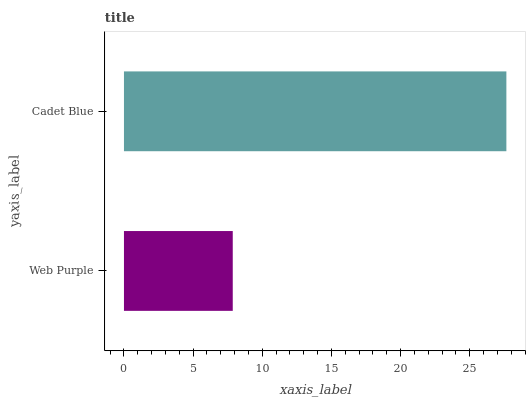Is Web Purple the minimum?
Answer yes or no. Yes. Is Cadet Blue the maximum?
Answer yes or no. Yes. Is Cadet Blue the minimum?
Answer yes or no. No. Is Cadet Blue greater than Web Purple?
Answer yes or no. Yes. Is Web Purple less than Cadet Blue?
Answer yes or no. Yes. Is Web Purple greater than Cadet Blue?
Answer yes or no. No. Is Cadet Blue less than Web Purple?
Answer yes or no. No. Is Cadet Blue the high median?
Answer yes or no. Yes. Is Web Purple the low median?
Answer yes or no. Yes. Is Web Purple the high median?
Answer yes or no. No. Is Cadet Blue the low median?
Answer yes or no. No. 